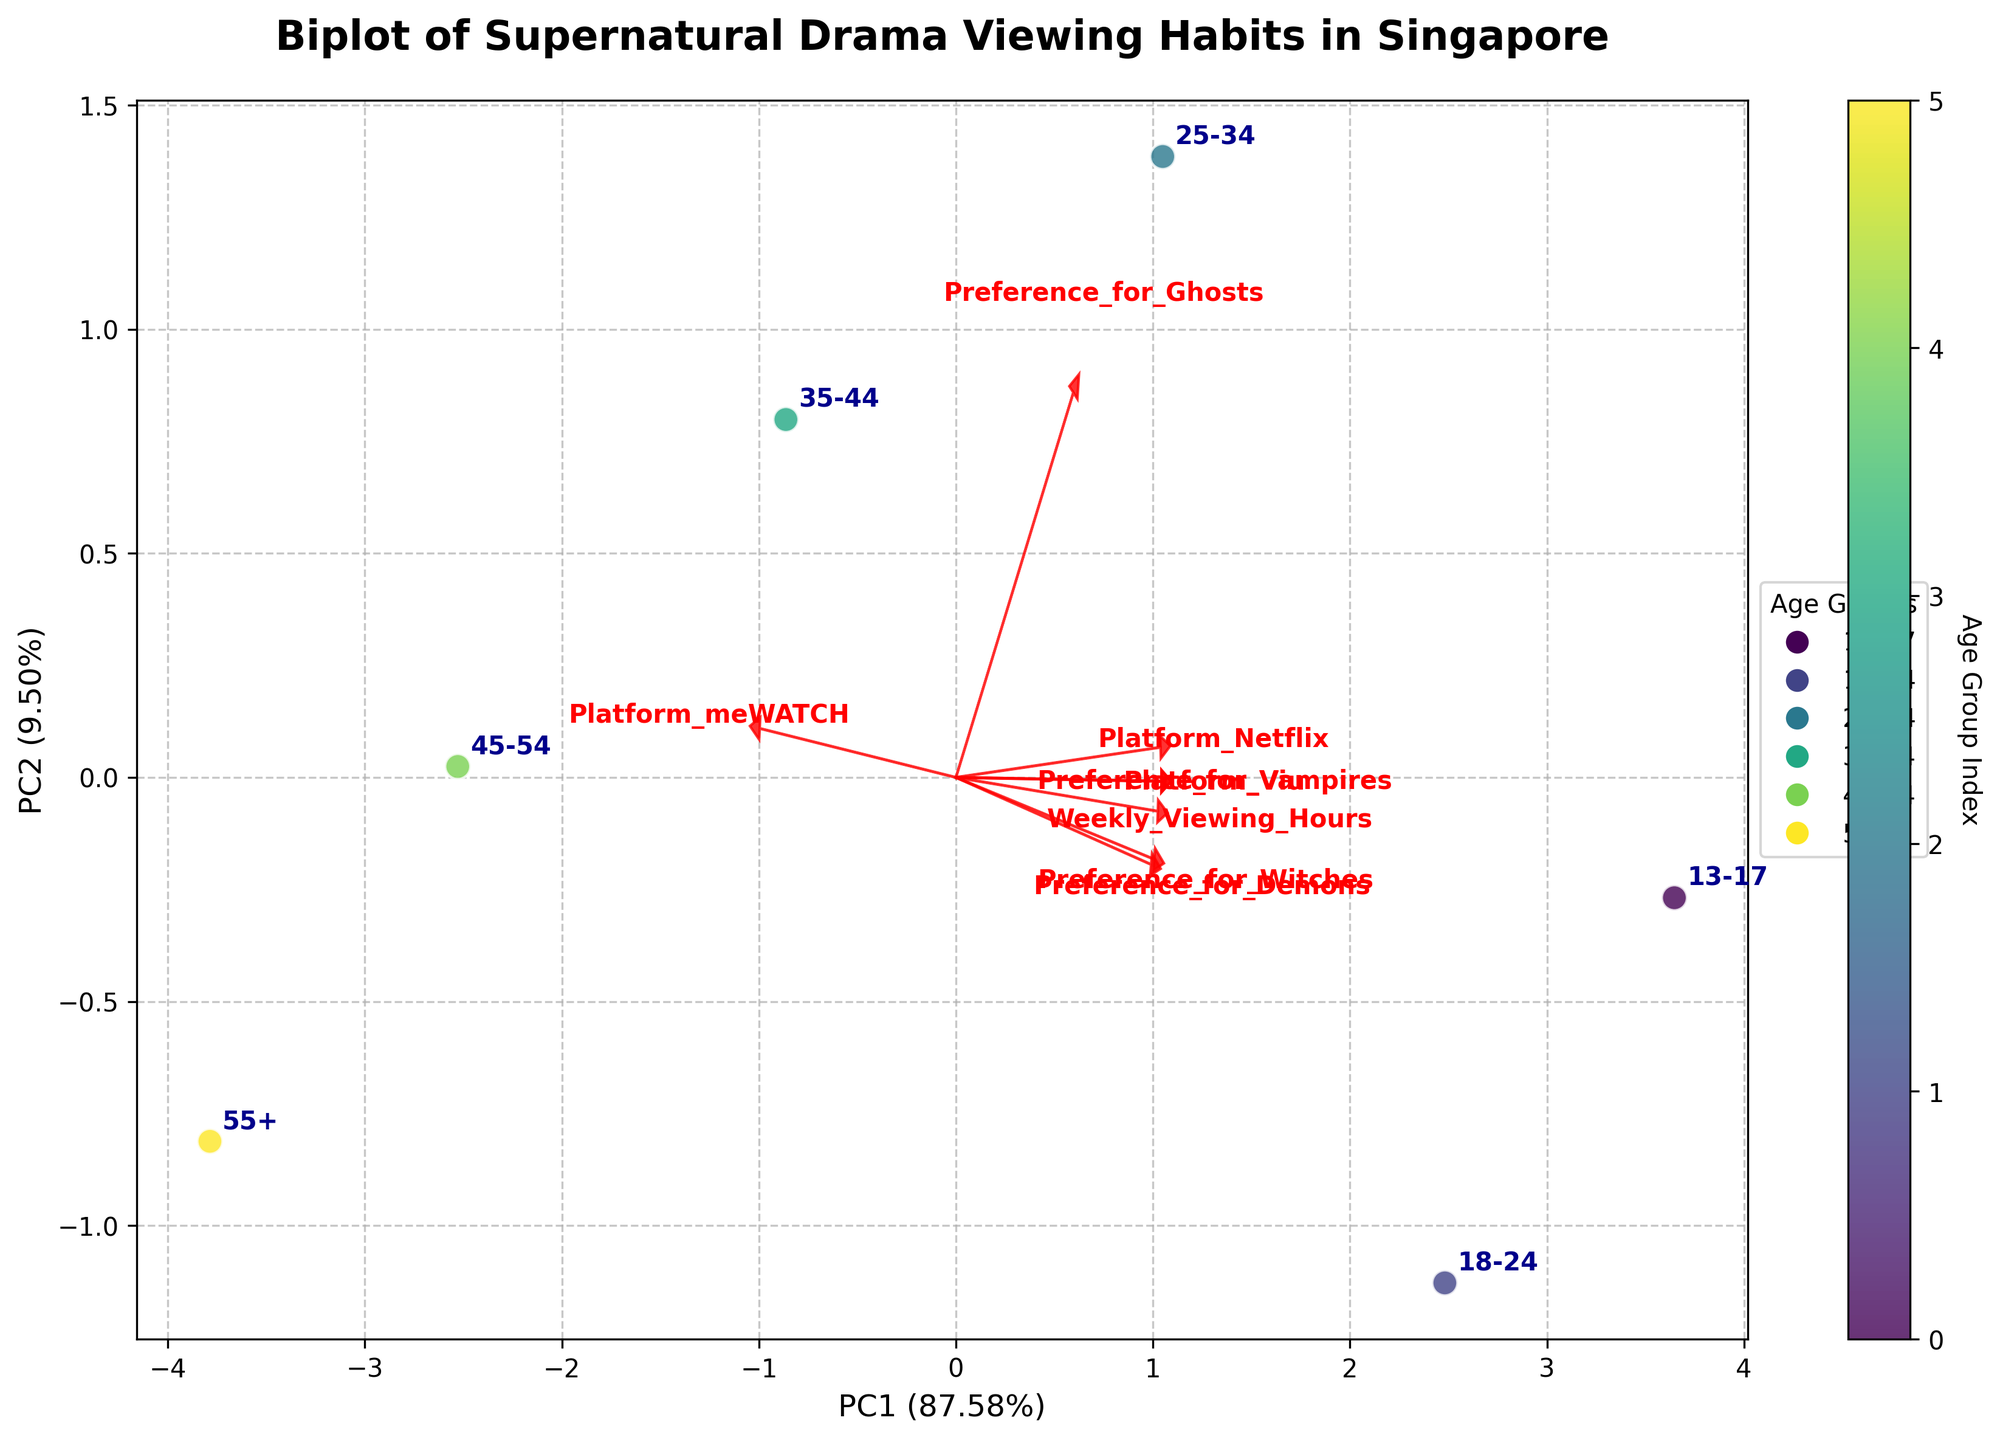What does the plot title say? The plot title is usually at the top of the figure. In this case, it states "Biplot of Supernatural Drama Viewing Habits in Singapore" which informs us about the relationship between viewing habits and preferences for supernatural dramas among different age groups.
Answer: Biplot of Supernatural Drama Viewing Habits in Singapore Which two components are represented on the x and y axes? The x and y axis labels will provide this information. Here, the x-axis represents "PC1" and the y-axis represents "PC2", indicating the two principal components used in the PCA.
Answer: PC1 and PC2 How many age groups are plotted in the figure? By identifying the unique labels on the plot, we can count the number of age groups. The plot shows the following age groups: 13-17, 18-24, 25-34, 35-44, 45-54, and 55+, so there are 6 age groups in total.
Answer: 6 Which age group has the highest preference for vampires based on its position relative to the "Preference_for_Vampires" arrow? The "Preference_for_Vampires" vector in the plot points in a direction, and the age group closest to the end of this vector will have the highest preference for vampires. Here, it is the 13-17 age group.
Answer: 13-17 How does the preference for demons vary between the age group 13-17 and 35-44? The arrows and their directions provide information on preferences. The 13-17 group's position relative to the "Preference_for_Demons" arrow is closer compared to the 35-44 group, indicating a higher preference. The 13-17 group prefers demons more than the 35-44 group.
Answer: The 13-17 group prefers demons more than the 35-44 group What platform is most associated with older age groups? The direction and magnitude of the platform vectors in the biplot give us this information. The "Platform_meWATCH" vector points more towards the older age groups like 45-54 and 55+.
Answer: Platform_meWATCH Which age group watches the most weekly hours of supernatural dramas? The position of each age group relative to the "Weekly_Viewing_Hours" vector will indicate this. The age group 13-17, which is closest to this vector, watches the most.
Answer: 13-17 Are preferences for witches and demons positively or negatively correlated? The loadings for each preference vector show how they are correlated. Since the "Preference_for_Witches" and "Preference_for_Demons" vectors point in slightly different directions, they are negatively correlated.
Answer: Negatively correlated What do the colors of the scatter points represent? From the color bar and the legend, the colors of the scatter points represent the different age groups. The color bar shows variations in colors that correspond to age group indices.
Answer: Different age groups Which platform has the least association with the 13-17 age group? Looking at the proximity of the 13-17 point to the vectors for platforms, "Platform_meWATCH" is the farthest, indicating it has the least association with this age group.
Answer: Platform_meWATCH 